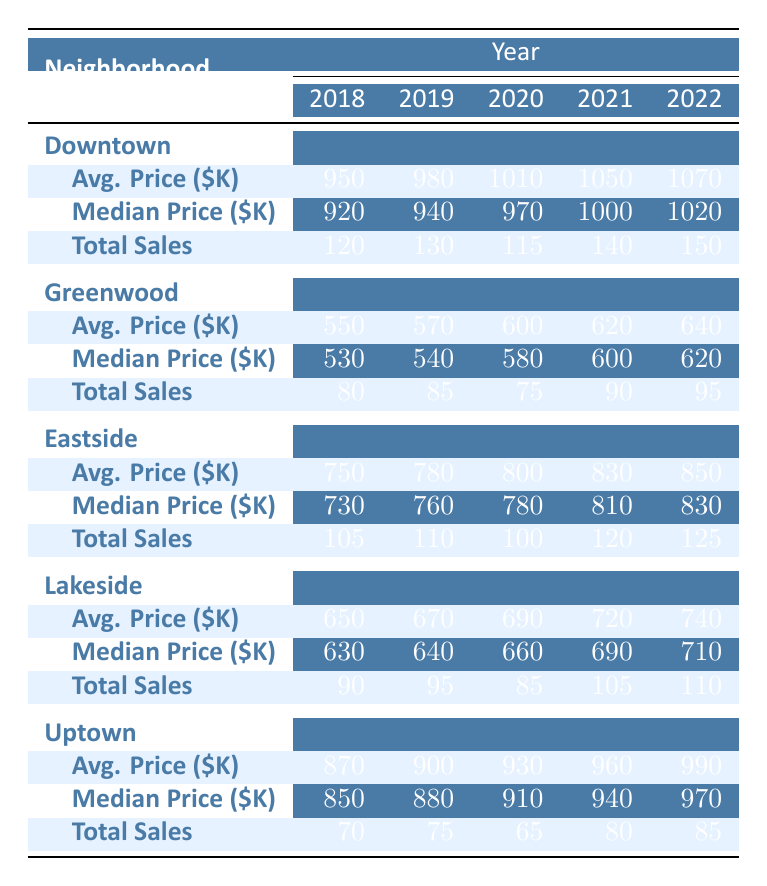What was the total sales in Downtown in 2021? The table shows that the total sales in Downtown for the year 2021 is listed as 140.
Answer: 140 What is the average price trend in Eastside from 2018 to 2022? The average prices for Eastside over these years are: 2018: 750, 2019: 780, 2020: 800, 2021: 830, and 2022: 850. This indicates an increasing trend, as the average price rises each year.
Answer: Increasing trend What was the median price in Greenwood in 2020? Referring to the table, the median price in Greenwood for the year 2020 is noted as 580,000.
Answer: 580000 Did total sales in Lakeside increase from 2018 to 2022? The total sales in Lakeside for these years are as follows: 2018: 90, 2019: 95, 2020: 85, 2021: 105, and 2022: 110. After analyzing the data, we can see that it increased overall from 90 to 110 over the period.
Answer: Yes What was the difference in average price between Uptown in 2018 and 2022? The average price for Uptown in 2018 is 870,000 and in 2022 it is 990,000. The difference is calculated as 990,000 - 870,000 = 120,000.
Answer: 120000 Which neighborhood had the highest average price in 2022? Checking the table, in 2022, Downtown has an average price of 1,070,000, which is higher than the other neighborhoods listed.
Answer: Downtown What is the average total sales across all neighborhoods for the year 2021? The total sales in 2021 for each neighborhood are: Downtown: 140, Greenwood: 90, Eastside: 120, Lakeside: 105, Uptown: 80. Summing these gives us 140 + 90 + 120 + 105 + 80 = 535. To find the average, we divide by the number of neighborhoods (5): 535 / 5 = 107.
Answer: 107 Is it true that Eastside had more total sales than Uptown in 2022? In 2022, Eastside had total sales of 125 while Uptown had total sales of 85. Therefore, it is true that Eastside had more sales.
Answer: Yes What was the median price in Downtown in 2019? Looking at the table, the median price in Downtown for the year 2019 is 940,000.
Answer: 940000 